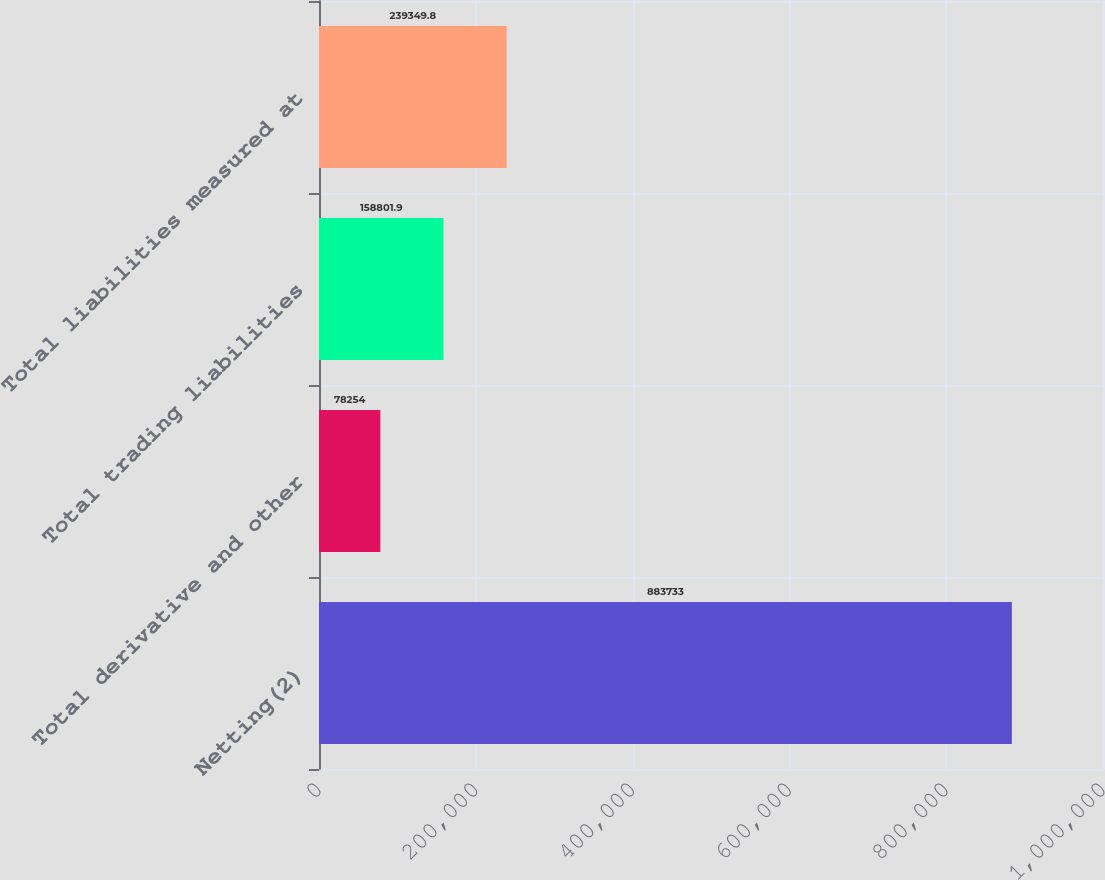Convert chart to OTSL. <chart><loc_0><loc_0><loc_500><loc_500><bar_chart><fcel>Netting(2)<fcel>Total derivative and other<fcel>Total trading liabilities<fcel>Total liabilities measured at<nl><fcel>883733<fcel>78254<fcel>158802<fcel>239350<nl></chart> 